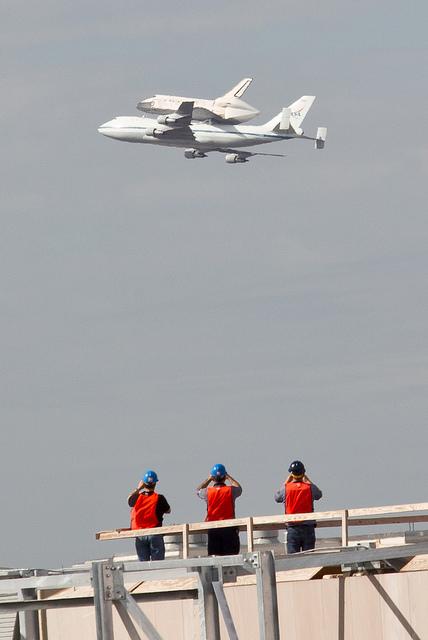How many blue hard hats are there?
Be succinct. 2. Does the plane have a baby?
Concise answer only. No. What is atop the 747?
Answer briefly. Space shuttle. 